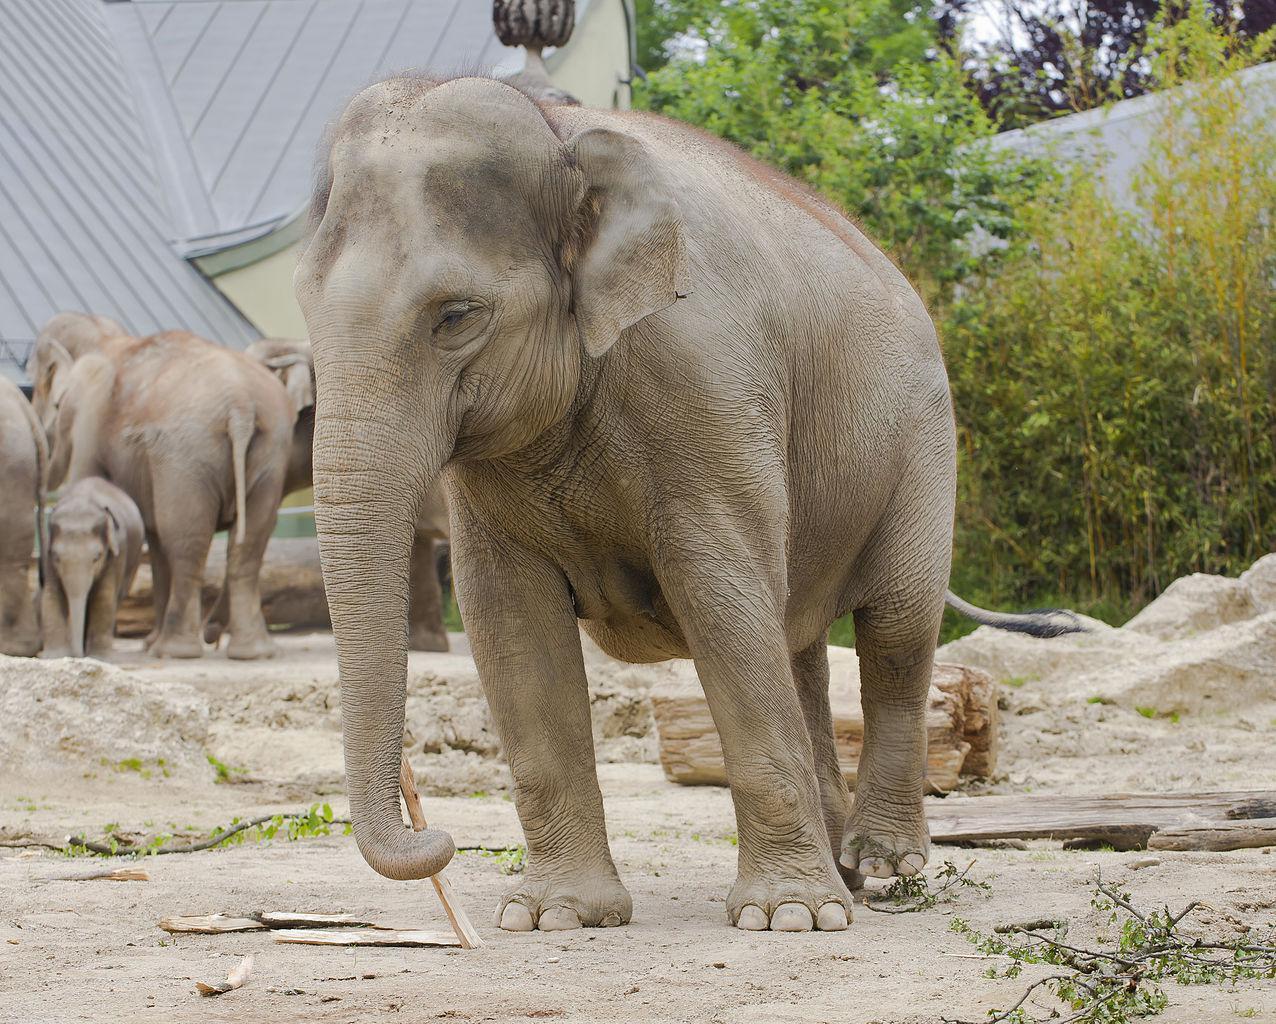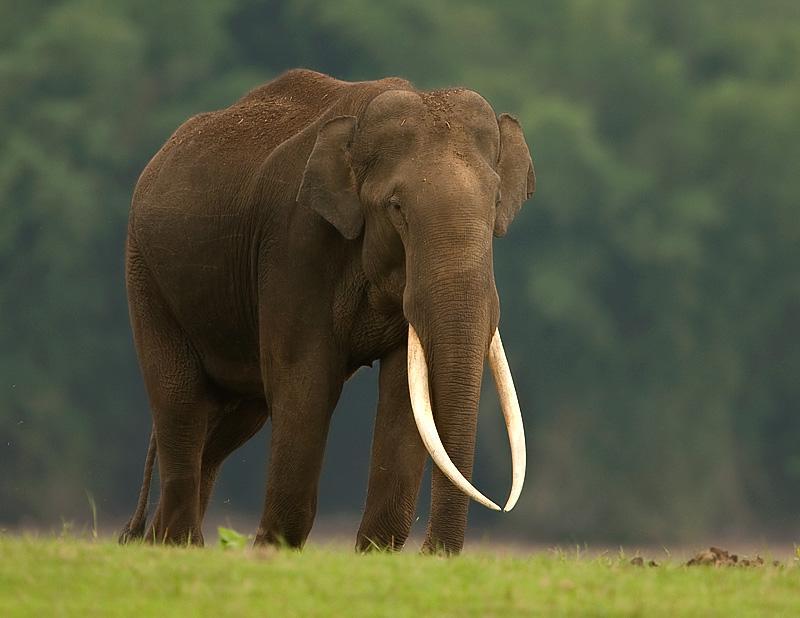The first image is the image on the left, the second image is the image on the right. Examine the images to the left and right. Is the description "A tusked elephant stands on a concrete area in the image on the right." accurate? Answer yes or no. No. 